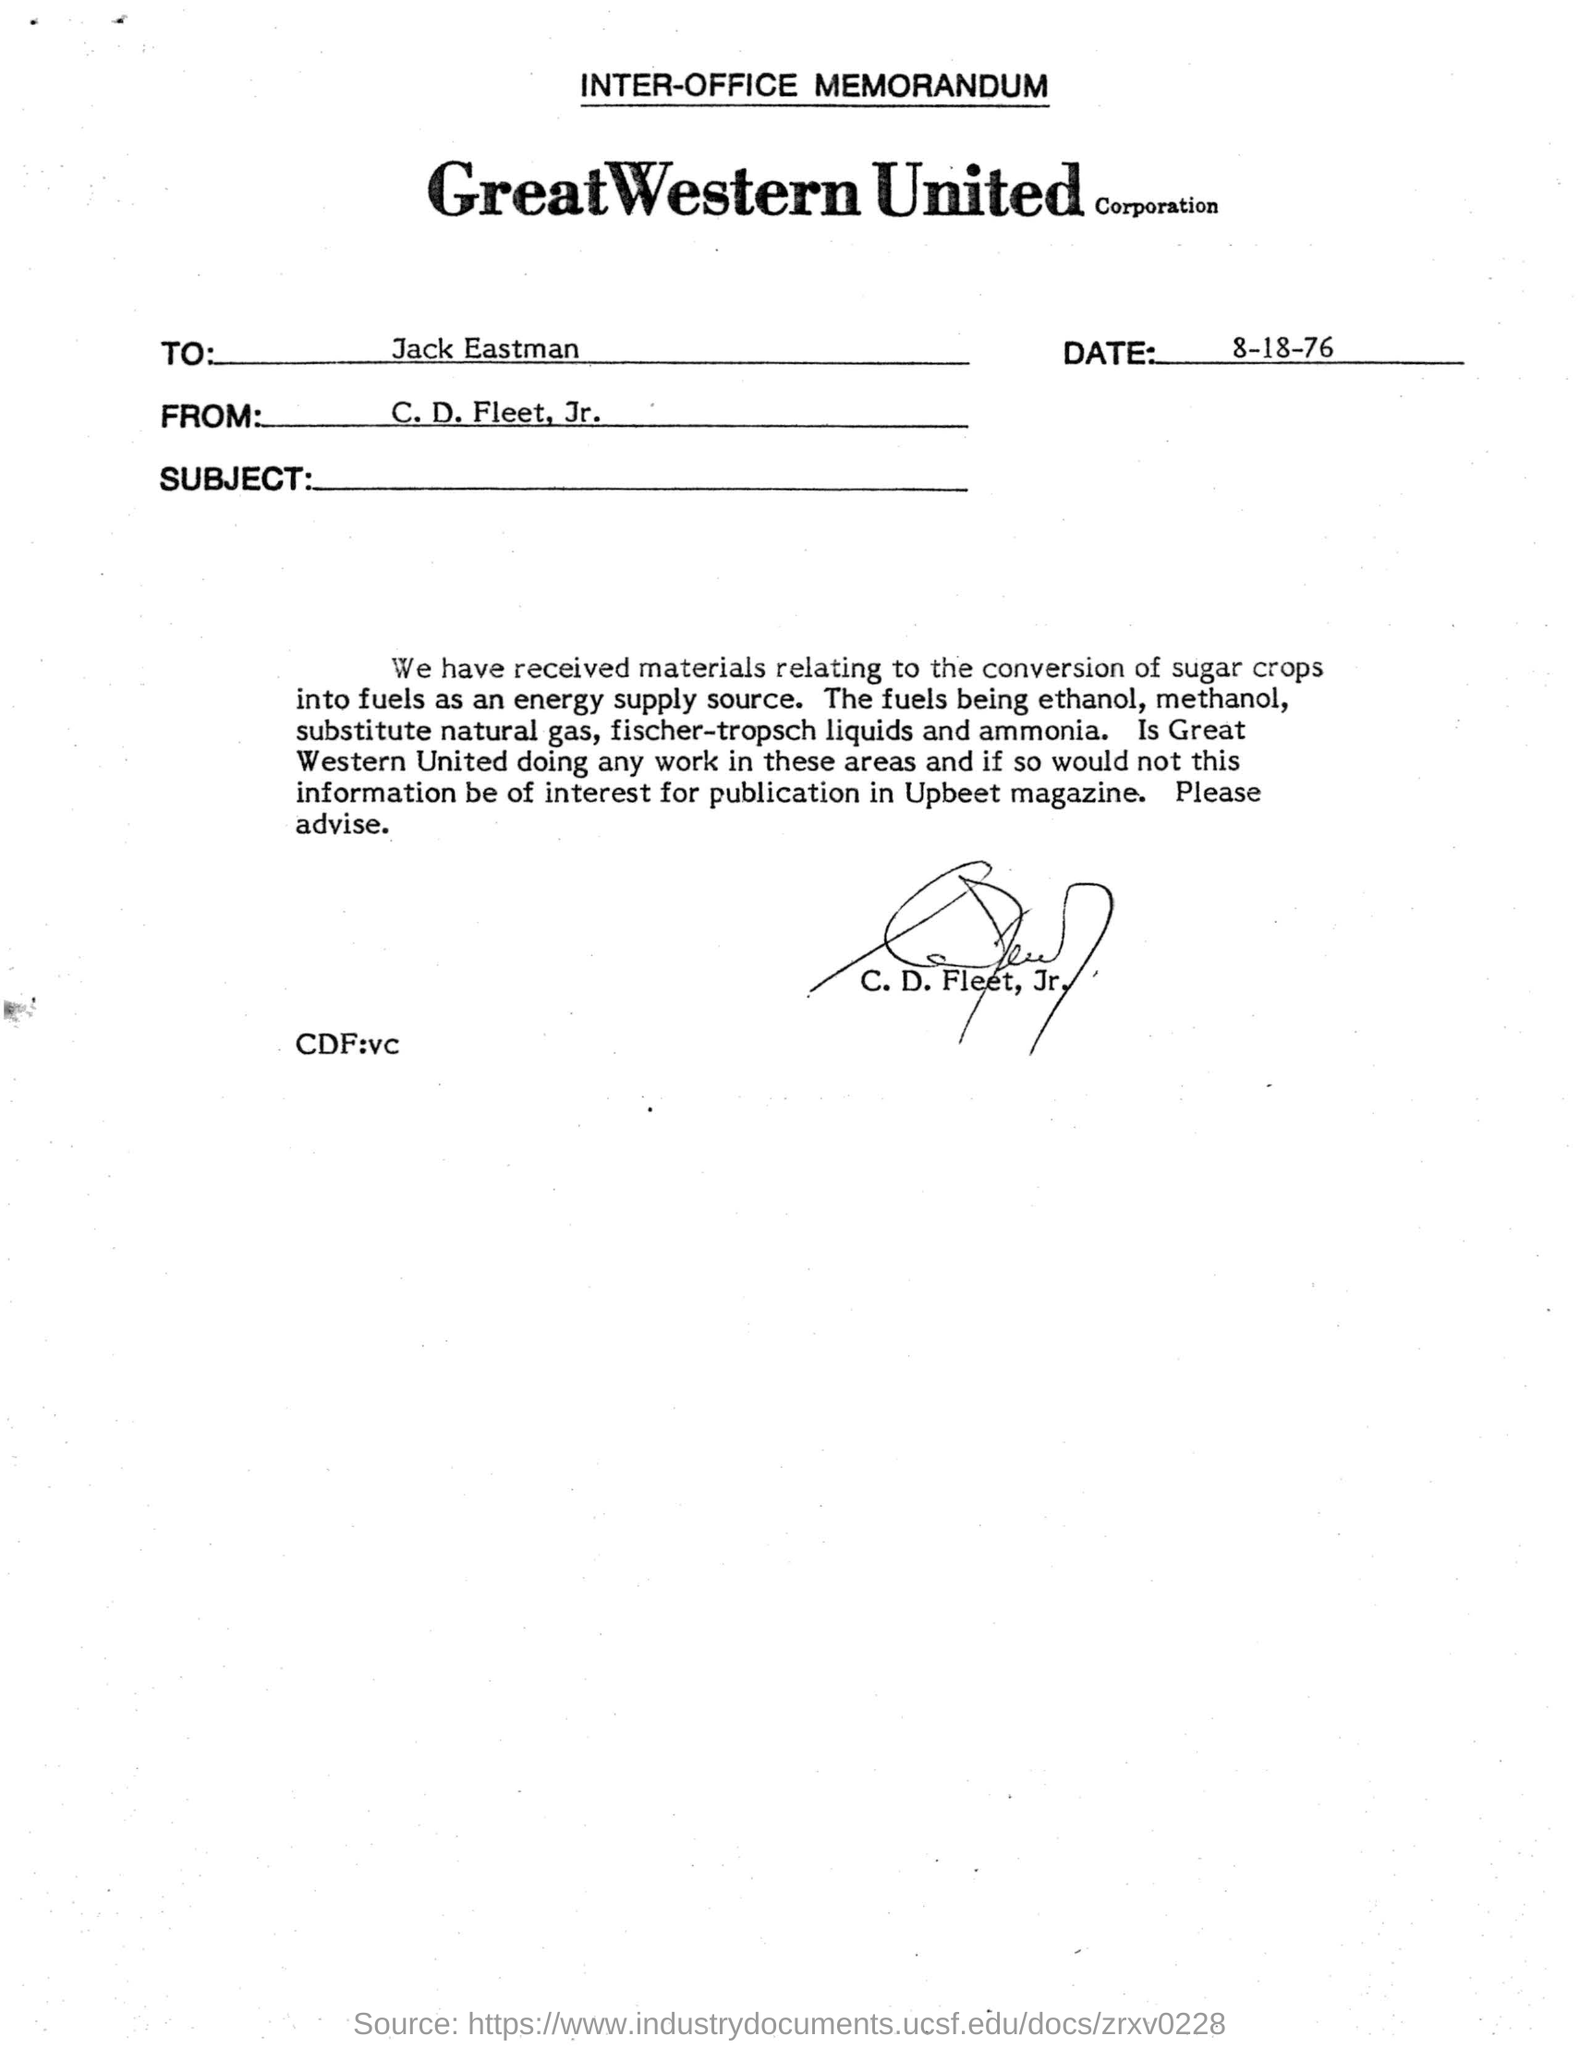Who has signed this memorandum?
Provide a short and direct response. C. D. Fleet, Jr. What is the date mentioned here?
Make the answer very short. 8-18-76. Who has signed the document?
Make the answer very short. C. D. Fleet, Jr. To whom the document is addressed to?
Provide a short and direct response. Jack Eastman. 